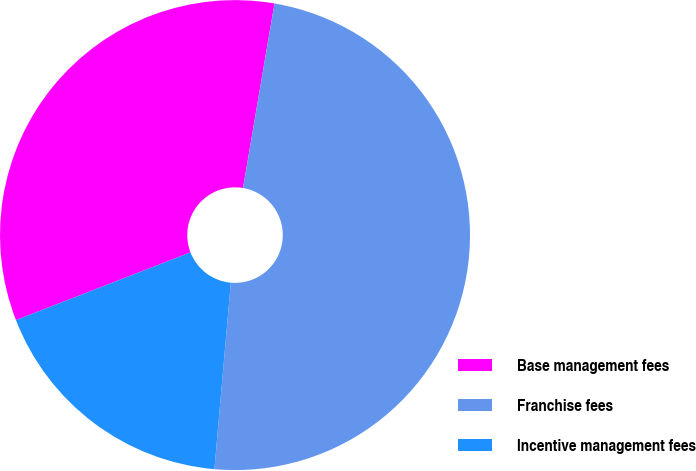<chart> <loc_0><loc_0><loc_500><loc_500><pie_chart><fcel>Base management fees<fcel>Franchise fees<fcel>Incentive management fees<nl><fcel>33.58%<fcel>48.71%<fcel>17.71%<nl></chart> 